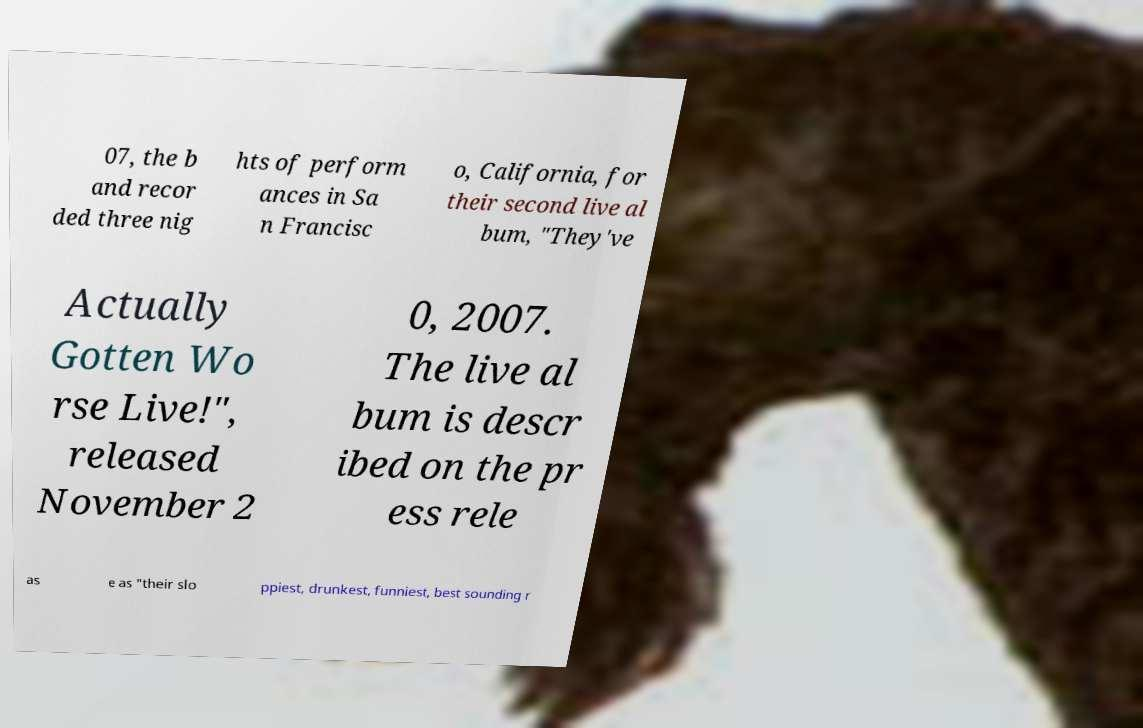Could you extract and type out the text from this image? 07, the b and recor ded three nig hts of perform ances in Sa n Francisc o, California, for their second live al bum, "They've Actually Gotten Wo rse Live!", released November 2 0, 2007. The live al bum is descr ibed on the pr ess rele as e as "their slo ppiest, drunkest, funniest, best sounding r 